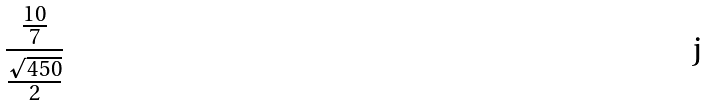Convert formula to latex. <formula><loc_0><loc_0><loc_500><loc_500>\frac { \frac { 1 0 } { 7 } } { \frac { \sqrt { 4 5 0 } } { 2 } }</formula> 